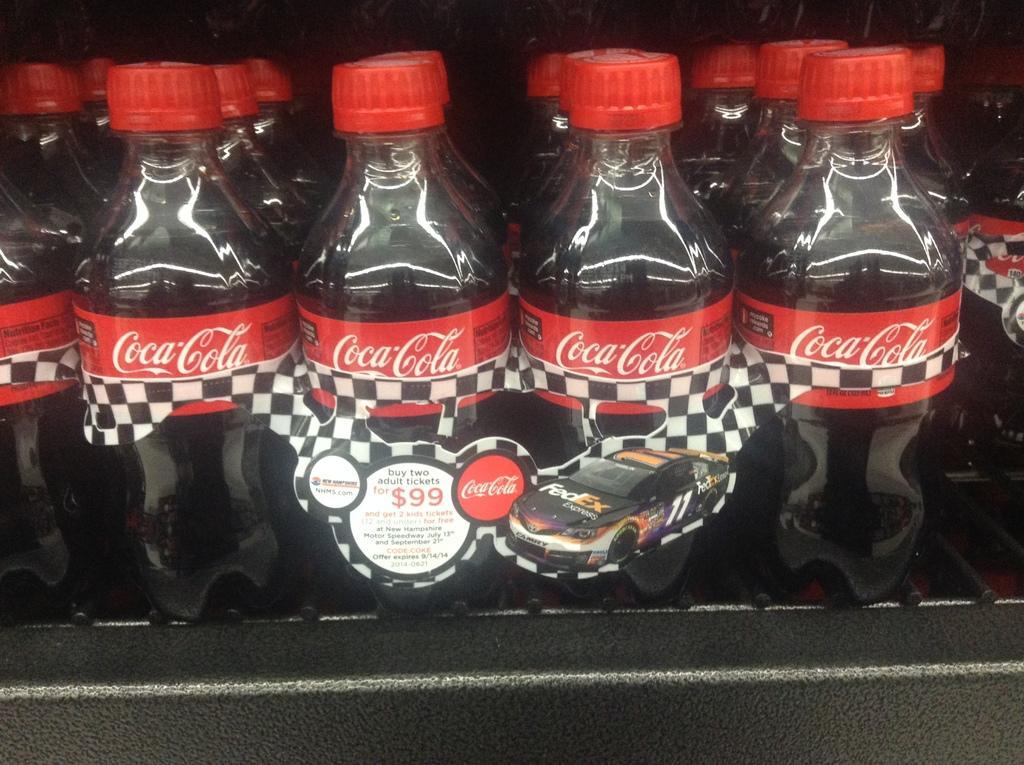Can you describe this image briefly? In this image there are cool drink bottles set. 